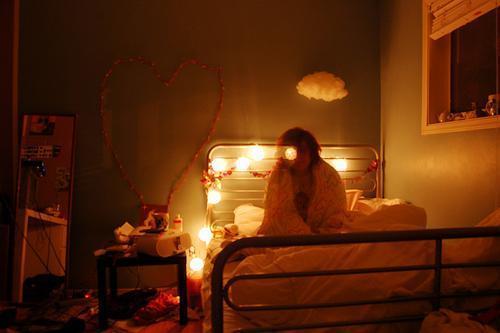How many people are the picture?
Give a very brief answer. 1. How many beds are in the image?
Give a very brief answer. 1. How many mirrors are in the room?
Give a very brief answer. 1. How many windows are in the photograph?
Give a very brief answer. 1. 